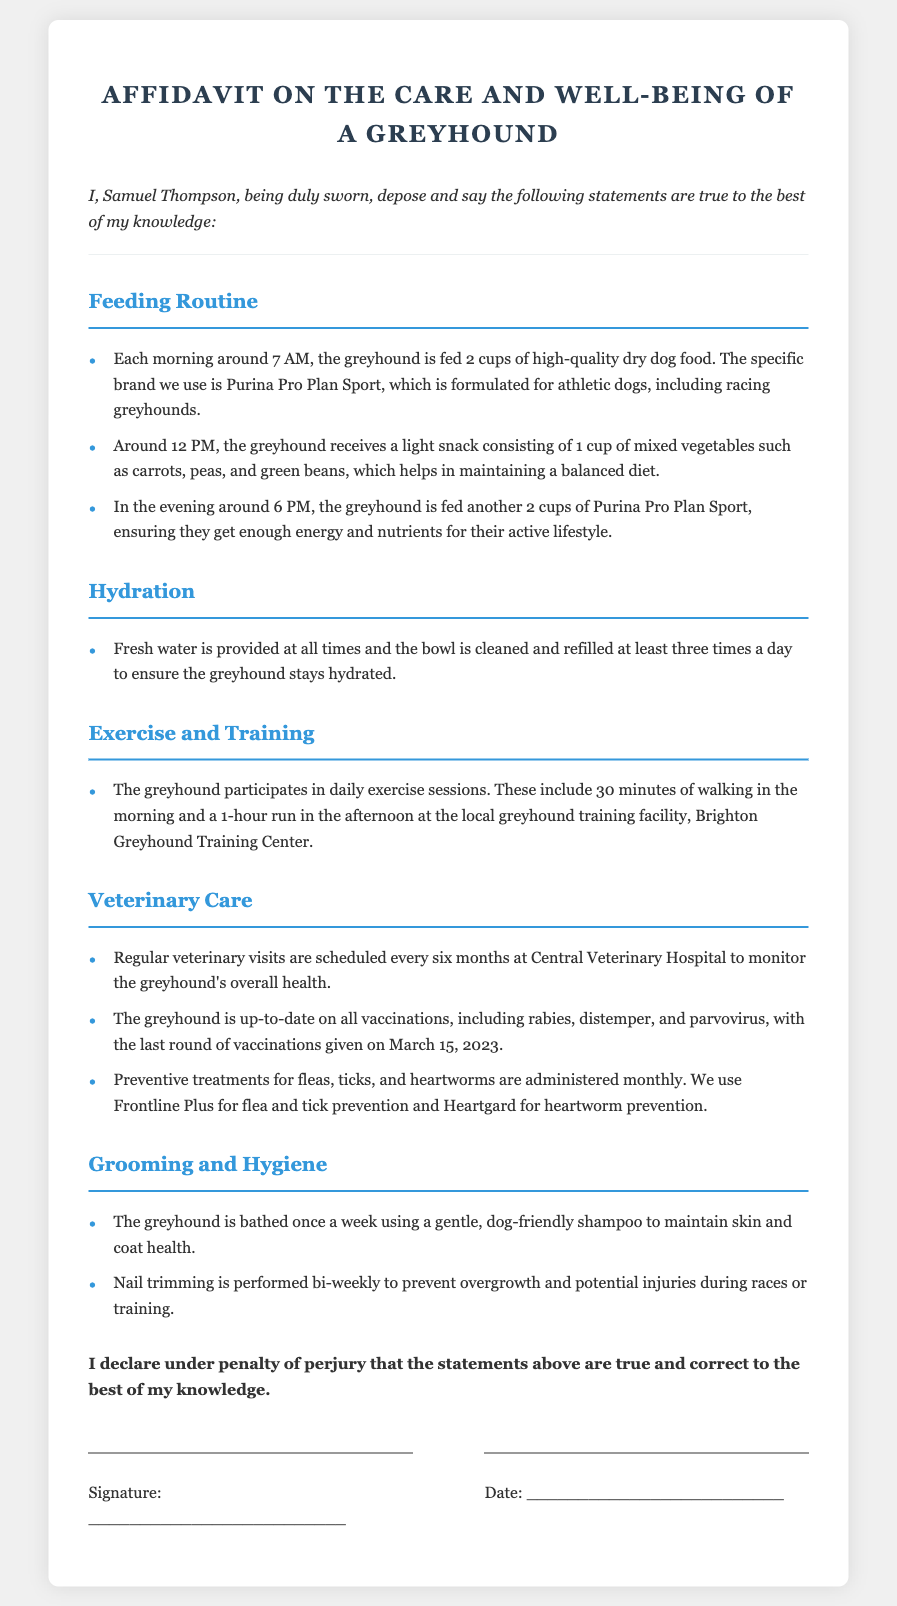What time is the greyhound fed in the morning? The affidavit states that the greyhound is fed each morning around 7 AM.
Answer: 7 AM What brand of food is used for the greyhound? The document specifies that the specific brand used is Purina Pro Plan Sport.
Answer: Purina Pro Plan Sport How often are veterinary visits scheduled? The affidavit indicates that regular veterinary visits are scheduled every six months.
Answer: Every six months When was the last round of vaccinations given? According to the document, the last round of vaccinations was given on March 15, 2023.
Answer: March 15, 2023 What is provided at all times for the greyhound? The affidavit mentions that fresh water is provided at all times.
Answer: Fresh water How many cups of mixed vegetables does the greyhound receive as a snack? The document states that the greyhound receives 1 cup of mixed vegetables for a light snack.
Answer: 1 cup What preventive treatment for heartworms is mentioned? The affidavit specifies that Heartgard is used for heartworm prevention.
Answer: Heartgard How frequently is the greyhound bathed? The document mentions that the greyhound is bathed once a week.
Answer: Once a week What type of exercise does the greyhound participate in? The affidavit indicates that the greyhound participates in daily exercise sessions, including walking and running.
Answer: Walking and running 